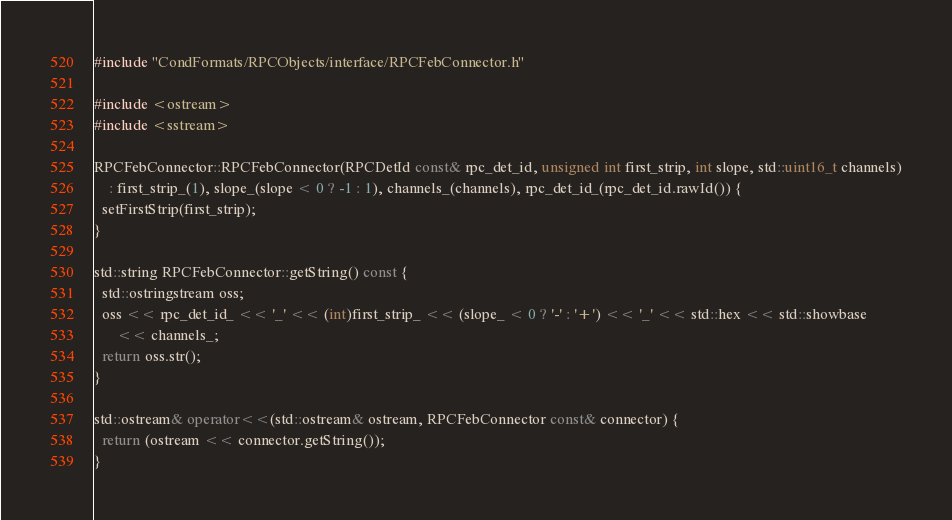Convert code to text. <code><loc_0><loc_0><loc_500><loc_500><_C++_>#include "CondFormats/RPCObjects/interface/RPCFebConnector.h"

#include <ostream>
#include <sstream>

RPCFebConnector::RPCFebConnector(RPCDetId const& rpc_det_id, unsigned int first_strip, int slope, std::uint16_t channels)
    : first_strip_(1), slope_(slope < 0 ? -1 : 1), channels_(channels), rpc_det_id_(rpc_det_id.rawId()) {
  setFirstStrip(first_strip);
}

std::string RPCFebConnector::getString() const {
  std::ostringstream oss;
  oss << rpc_det_id_ << '_' << (int)first_strip_ << (slope_ < 0 ? '-' : '+') << '_' << std::hex << std::showbase
      << channels_;
  return oss.str();
}

std::ostream& operator<<(std::ostream& ostream, RPCFebConnector const& connector) {
  return (ostream << connector.getString());
}
</code> 